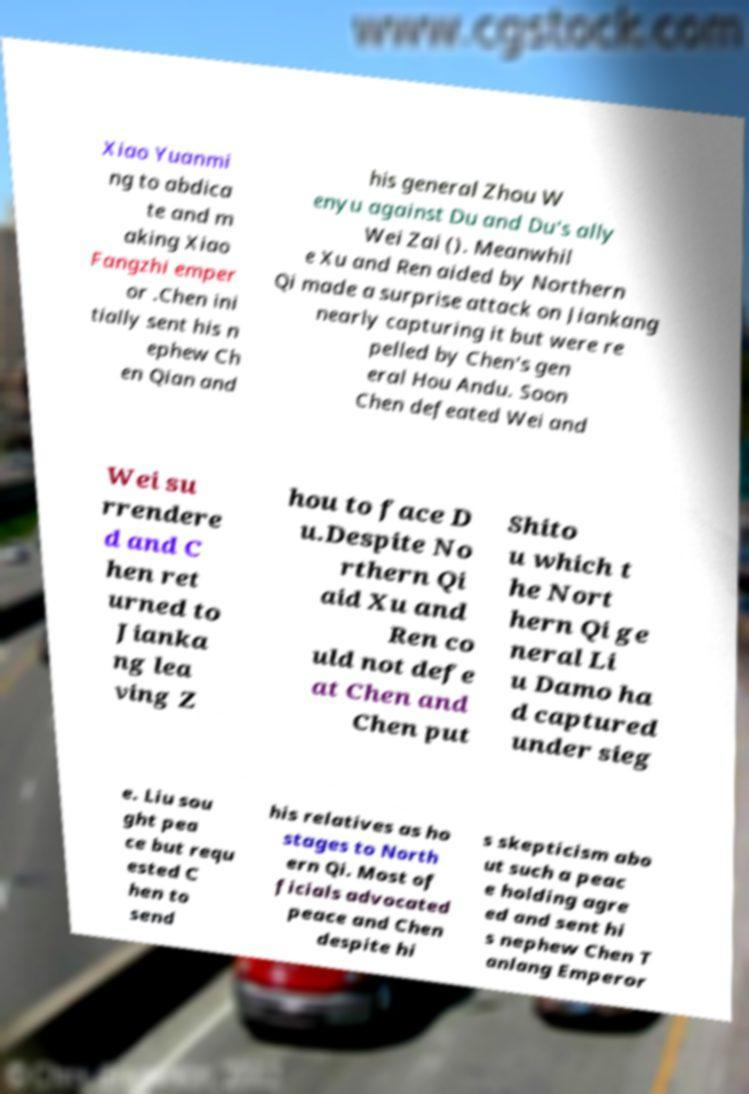Can you accurately transcribe the text from the provided image for me? Xiao Yuanmi ng to abdica te and m aking Xiao Fangzhi emper or .Chen ini tially sent his n ephew Ch en Qian and his general Zhou W enyu against Du and Du's ally Wei Zai (). Meanwhil e Xu and Ren aided by Northern Qi made a surprise attack on Jiankang nearly capturing it but were re pelled by Chen's gen eral Hou Andu. Soon Chen defeated Wei and Wei su rrendere d and C hen ret urned to Jianka ng lea ving Z hou to face D u.Despite No rthern Qi aid Xu and Ren co uld not defe at Chen and Chen put Shito u which t he Nort hern Qi ge neral Li u Damo ha d captured under sieg e. Liu sou ght pea ce but requ ested C hen to send his relatives as ho stages to North ern Qi. Most of ficials advocated peace and Chen despite hi s skepticism abo ut such a peac e holding agre ed and sent hi s nephew Chen T anlang Emperor 